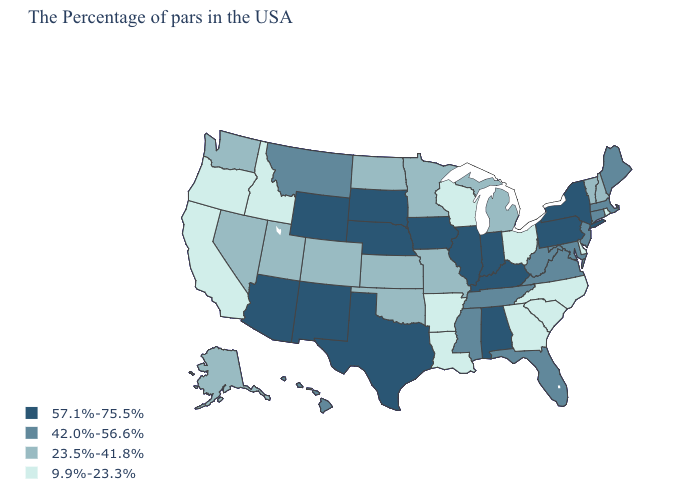Among the states that border Michigan , does Indiana have the lowest value?
Concise answer only. No. Name the states that have a value in the range 9.9%-23.3%?
Be succinct. Rhode Island, Delaware, North Carolina, South Carolina, Ohio, Georgia, Wisconsin, Louisiana, Arkansas, Idaho, California, Oregon. What is the highest value in the USA?
Be succinct. 57.1%-75.5%. What is the value of New Hampshire?
Quick response, please. 23.5%-41.8%. What is the value of South Carolina?
Keep it brief. 9.9%-23.3%. Does New York have the lowest value in the Northeast?
Short answer required. No. What is the value of Wyoming?
Short answer required. 57.1%-75.5%. Does Illinois have the highest value in the USA?
Write a very short answer. Yes. What is the highest value in the USA?
Answer briefly. 57.1%-75.5%. How many symbols are there in the legend?
Be succinct. 4. What is the lowest value in states that border Illinois?
Give a very brief answer. 9.9%-23.3%. What is the lowest value in the MidWest?
Answer briefly. 9.9%-23.3%. Which states hav the highest value in the Northeast?
Write a very short answer. New York, Pennsylvania. What is the lowest value in the USA?
Answer briefly. 9.9%-23.3%. Does Mississippi have the highest value in the USA?
Answer briefly. No. 